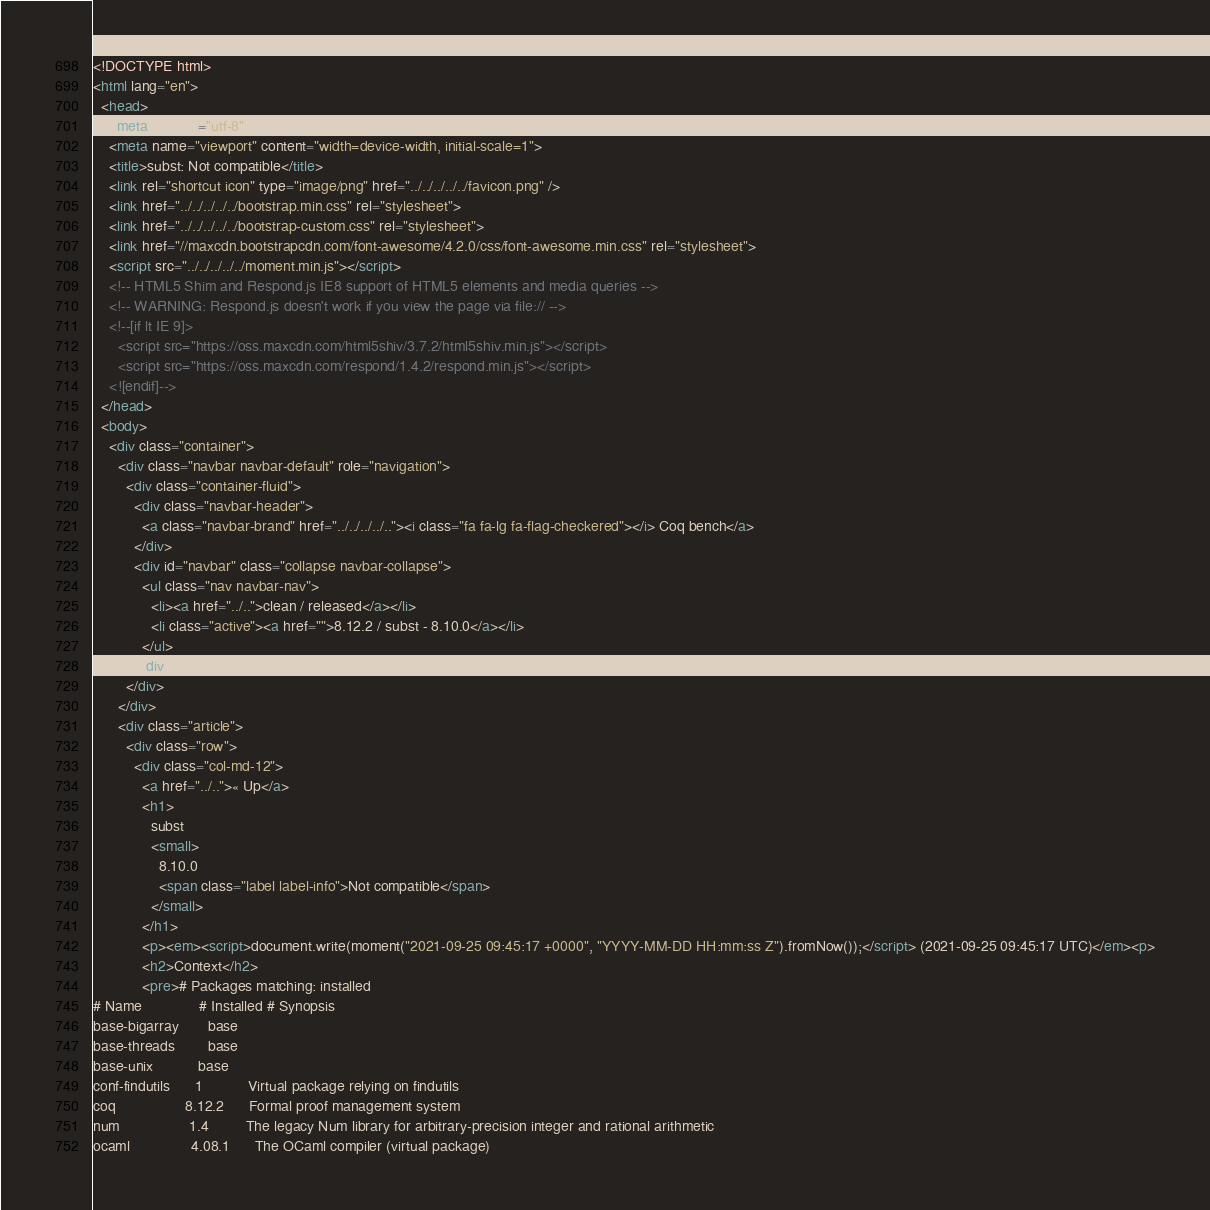<code> <loc_0><loc_0><loc_500><loc_500><_HTML_><!DOCTYPE html>
<html lang="en">
  <head>
    <meta charset="utf-8">
    <meta name="viewport" content="width=device-width, initial-scale=1">
    <title>subst: Not compatible</title>
    <link rel="shortcut icon" type="image/png" href="../../../../../favicon.png" />
    <link href="../../../../../bootstrap.min.css" rel="stylesheet">
    <link href="../../../../../bootstrap-custom.css" rel="stylesheet">
    <link href="//maxcdn.bootstrapcdn.com/font-awesome/4.2.0/css/font-awesome.min.css" rel="stylesheet">
    <script src="../../../../../moment.min.js"></script>
    <!-- HTML5 Shim and Respond.js IE8 support of HTML5 elements and media queries -->
    <!-- WARNING: Respond.js doesn't work if you view the page via file:// -->
    <!--[if lt IE 9]>
      <script src="https://oss.maxcdn.com/html5shiv/3.7.2/html5shiv.min.js"></script>
      <script src="https://oss.maxcdn.com/respond/1.4.2/respond.min.js"></script>
    <![endif]-->
  </head>
  <body>
    <div class="container">
      <div class="navbar navbar-default" role="navigation">
        <div class="container-fluid">
          <div class="navbar-header">
            <a class="navbar-brand" href="../../../../.."><i class="fa fa-lg fa-flag-checkered"></i> Coq bench</a>
          </div>
          <div id="navbar" class="collapse navbar-collapse">
            <ul class="nav navbar-nav">
              <li><a href="../..">clean / released</a></li>
              <li class="active"><a href="">8.12.2 / subst - 8.10.0</a></li>
            </ul>
          </div>
        </div>
      </div>
      <div class="article">
        <div class="row">
          <div class="col-md-12">
            <a href="../..">« Up</a>
            <h1>
              subst
              <small>
                8.10.0
                <span class="label label-info">Not compatible</span>
              </small>
            </h1>
            <p><em><script>document.write(moment("2021-09-25 09:45:17 +0000", "YYYY-MM-DD HH:mm:ss Z").fromNow());</script> (2021-09-25 09:45:17 UTC)</em><p>
            <h2>Context</h2>
            <pre># Packages matching: installed
# Name              # Installed # Synopsis
base-bigarray       base
base-threads        base
base-unix           base
conf-findutils      1           Virtual package relying on findutils
coq                 8.12.2      Formal proof management system
num                 1.4         The legacy Num library for arbitrary-precision integer and rational arithmetic
ocaml               4.08.1      The OCaml compiler (virtual package)</code> 